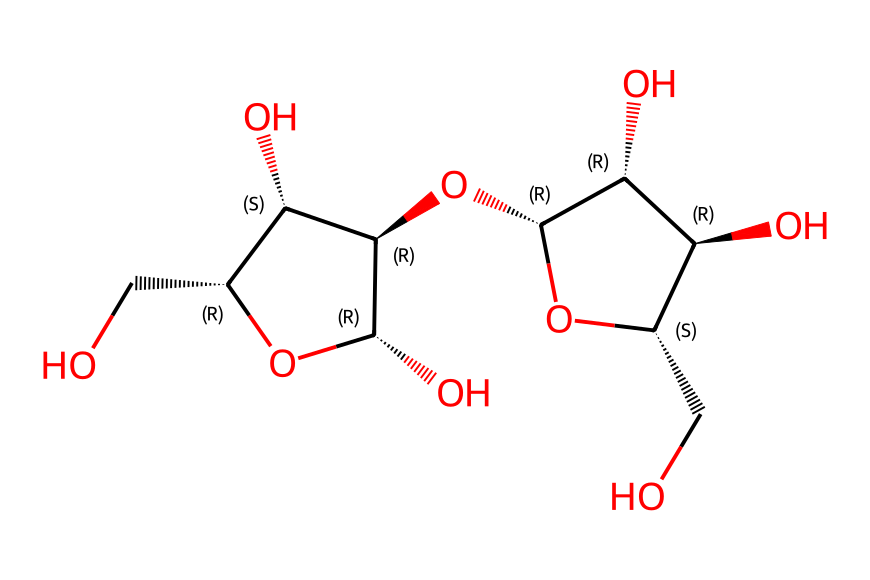What is the fundamental unit of this chemical? The structure presented is a representation of cellulose, which is a polysaccharide made up of repeating units of glucose. The presence of multiple hydroxyl (-OH) groups and the specific arrangement of carbon atoms indicates that it is composed of glucose monomers.
Answer: glucose How many carbon atoms are present in the chemical structure? To determine the number of carbon atoms, you count the 'C' atoms in the SMILES notation. In this case, the notation reveals that there are six carbon atoms within the repeating unit of glucose.
Answer: six What type of bonding is predominantly seen in this chemical structure? The predominant bonding in cellulose is glycosidic bonding between glucose units. This is indicated by the cyclic structure and the connections shown between multiple sugar units, which form long chains typical of polysaccharides.
Answer: glycosidic How many hydroxyl groups (-OH) are in the structure? Count the occurrences of -OH groups in the structure, which are implied by the oxygen atoms connected to carbons in the SMILES representation. There are three hydroxyl groups in this structure related to each glucose unit.
Answer: three What is the significance of cellulose in composite materials for wind turbine blades? Cellulose provides structural integrity due to its strength and fibrous nature, which contributes to the composite's mechanical properties, making it an essential component in constructing lightweight and durable wind turbine blades.
Answer: structural integrity 